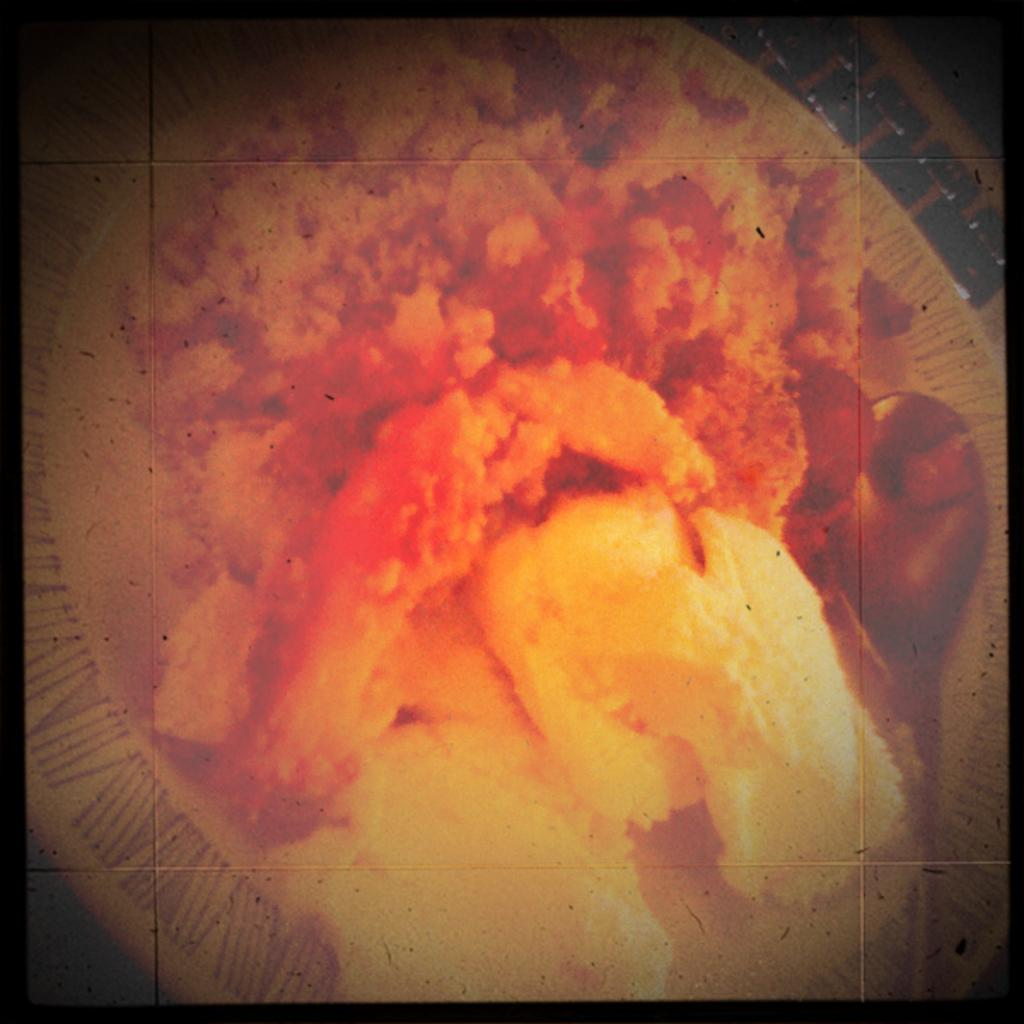What object is visible in the image that might be used for serving or holding food? There is a plate in the image. What can be found on the plate in the image? There is food present in the plate. Can you see any hands holding the plate in the image? There are no hands visible in the image, as it only shows a plate with food on it. Is there a drawer visible in the image? There is no drawer present in the image. 